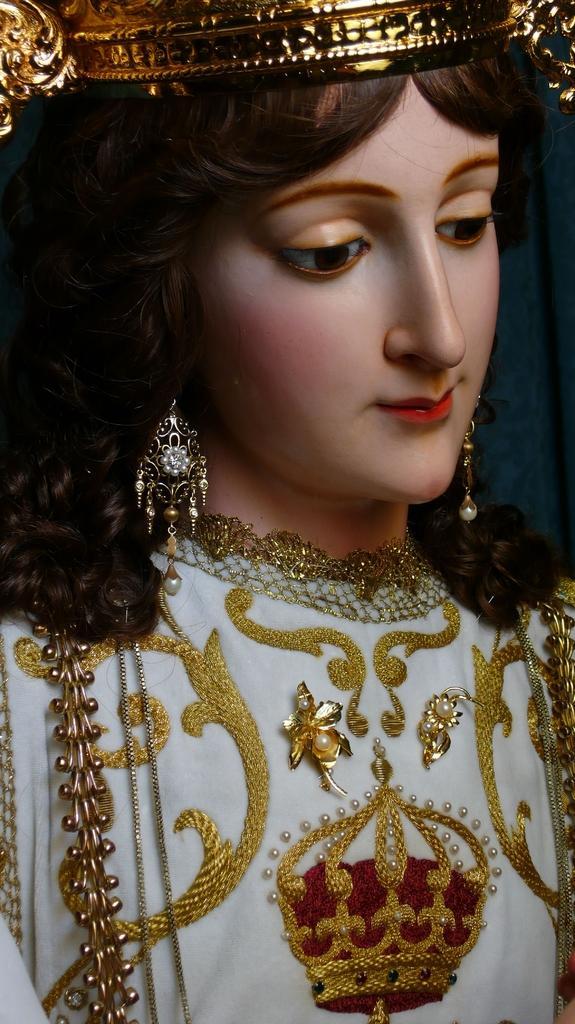In one or two sentences, can you explain what this image depicts? In this image there is a sculpture of a girl. There are earrings and a dress on the sculpture. At the top there is a crown on the head of the sculpture. 